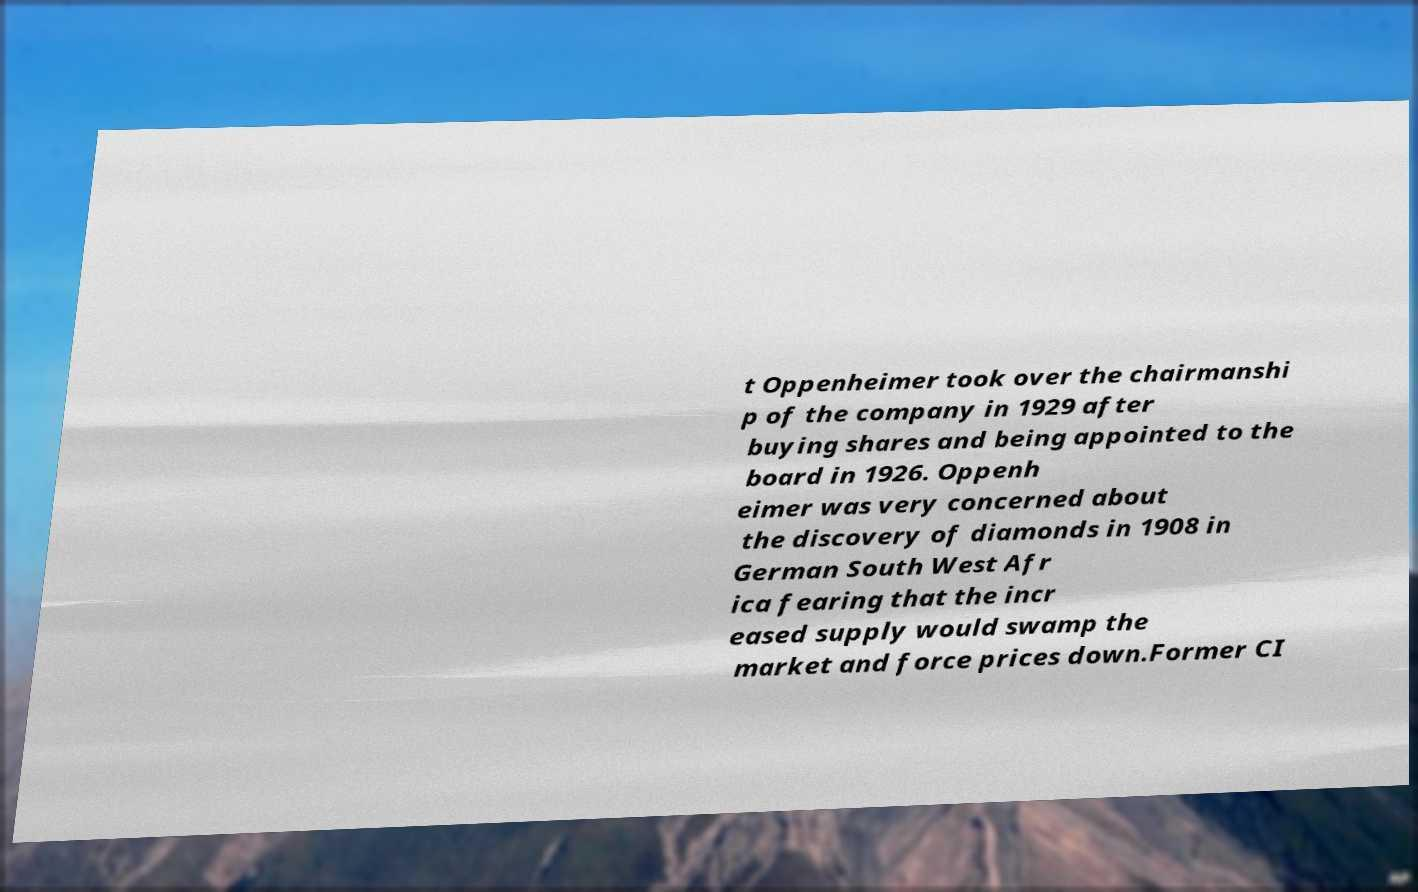There's text embedded in this image that I need extracted. Can you transcribe it verbatim? t Oppenheimer took over the chairmanshi p of the company in 1929 after buying shares and being appointed to the board in 1926. Oppenh eimer was very concerned about the discovery of diamonds in 1908 in German South West Afr ica fearing that the incr eased supply would swamp the market and force prices down.Former CI 